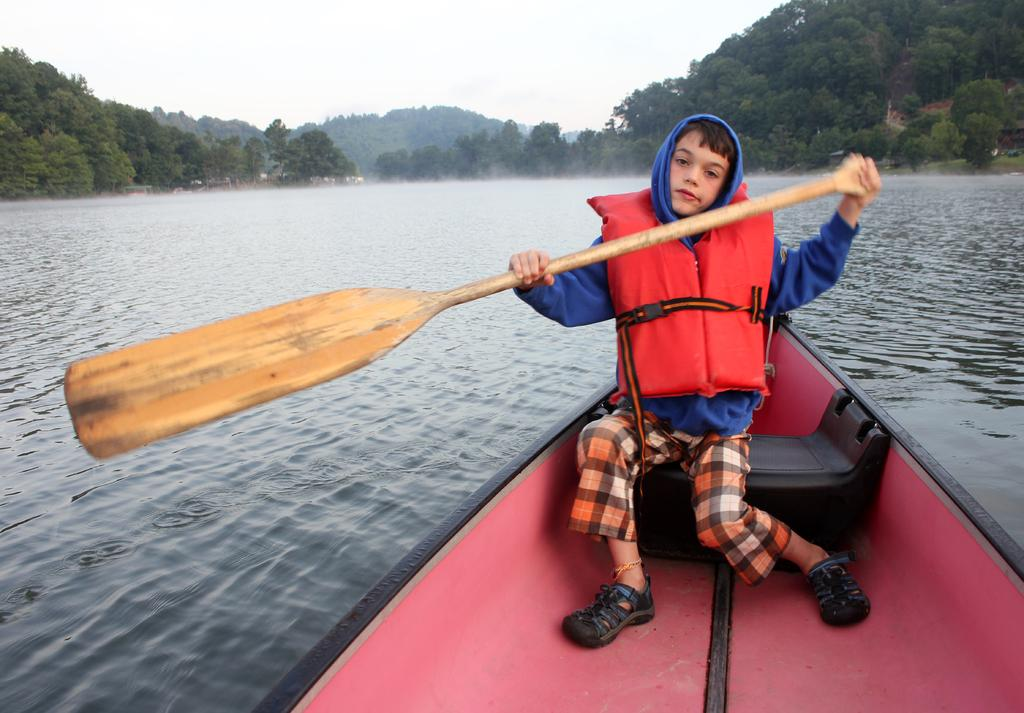Who is the main subject in the image? There is a boy in the image. What is the boy wearing? The boy is wearing a hoodie and a life jacket. What is the boy holding in the image? The boy is holding a paddle. Where is the boy sitting? The boy is sitting in a boat. What is the location of the boat? The boat is on the water. What can be seen in the background of the image? There is sky and trees visible in the background of the image. What type of jeans is the boy wearing in the image? The boy is not wearing jeans in the image; he is wearing a hoodie and a life jacket. What force is being applied to the boat in the image? There is no indication of any force being applied to the boat in the image; it is simply floating on the water. 